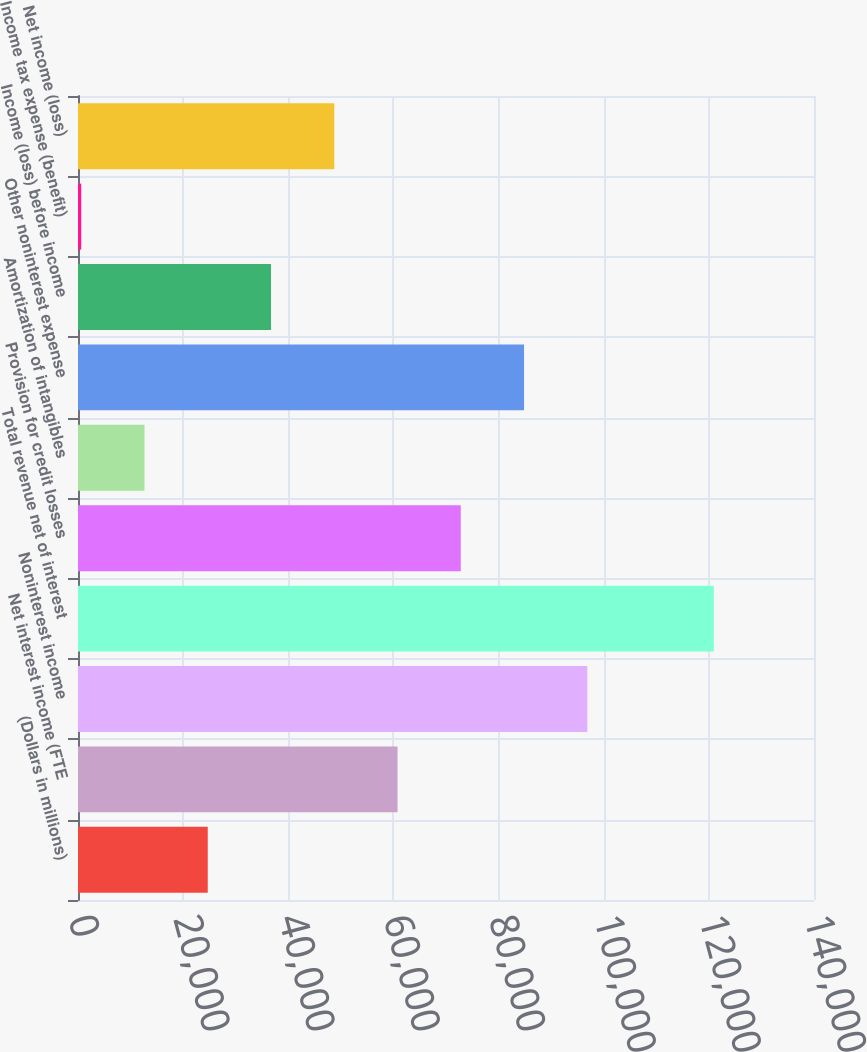<chart> <loc_0><loc_0><loc_500><loc_500><bar_chart><fcel>(Dollars in millions)<fcel>Net interest income (FTE<fcel>Noninterest income<fcel>Total revenue net of interest<fcel>Provision for credit losses<fcel>Amortization of intangibles<fcel>Other noninterest expense<fcel>Income (loss) before income<fcel>Income tax expense (benefit)<fcel>Net income (loss)<nl><fcel>24680.8<fcel>60779.5<fcel>96878.2<fcel>120944<fcel>72812.4<fcel>12647.9<fcel>84845.3<fcel>36713.7<fcel>615<fcel>48746.6<nl></chart> 